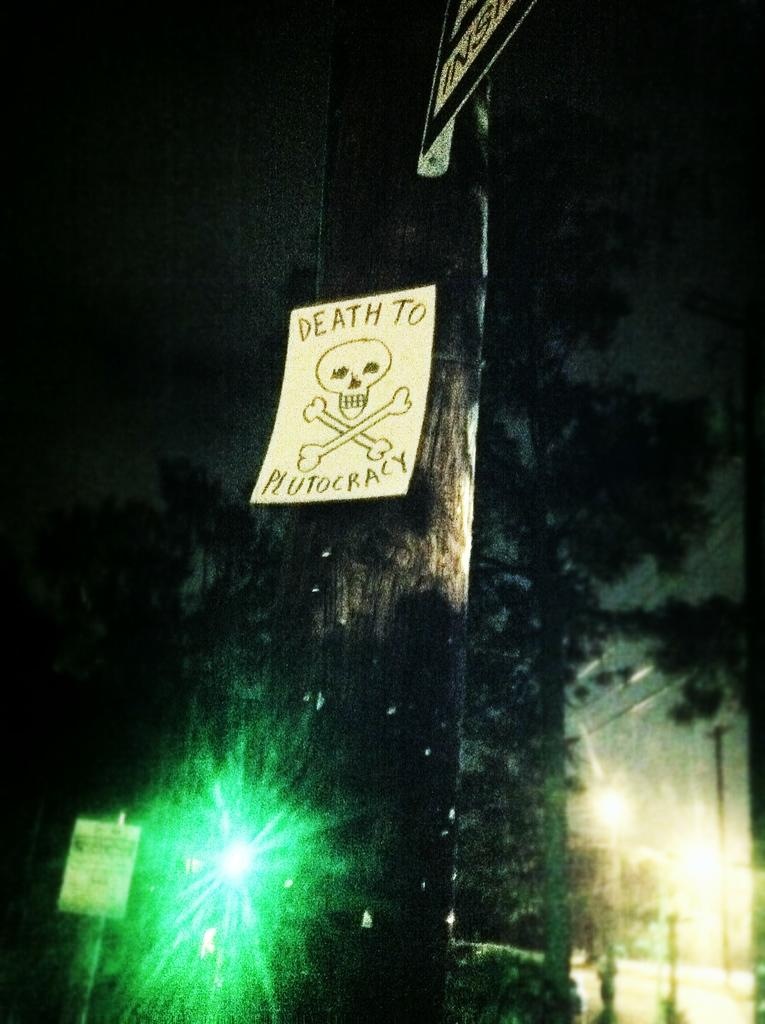What is attached to the pole in the image? There is a paper attached to a pole in the image. What color light can be seen in the background? There is a green light visible in the background. What is located in the background of the image? There is a board and trees present in the background. What is the color of the background in the image? The background has a black color. What type of soda is the daughter drinking in the image? There is no daughter or soda present in the image. 